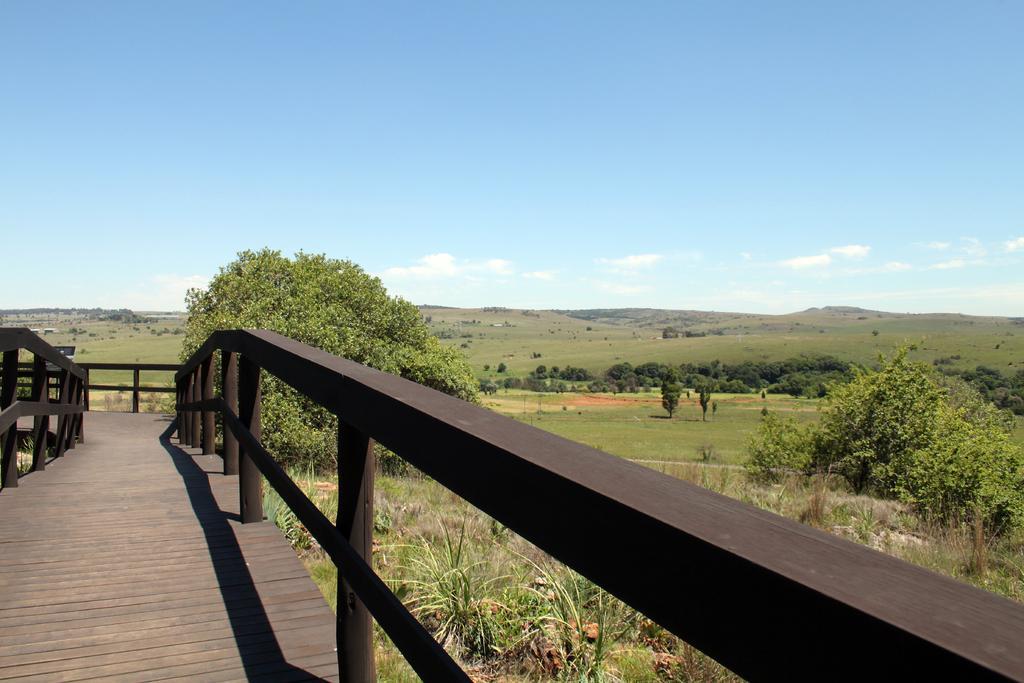How would you summarize this image in a sentence or two? In this picture I can see a fence. In the background I can see trees, grass and the sky. 